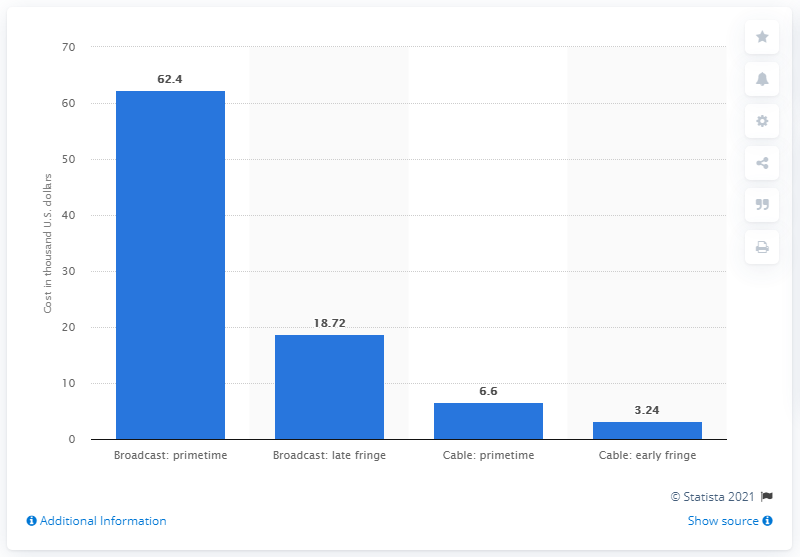Identify some key points in this picture. In July 2016, the average cost of a 30-second primetime TV spot in the United States was 62.4 dollars. 